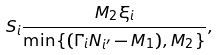Convert formula to latex. <formula><loc_0><loc_0><loc_500><loc_500>S _ { i } & \frac { M _ { 2 } \xi _ { i } } { \min \{ ( \Gamma _ { i } N _ { i ^ { \prime } } - M _ { 1 } ) , M _ { 2 } \} } ,</formula> 